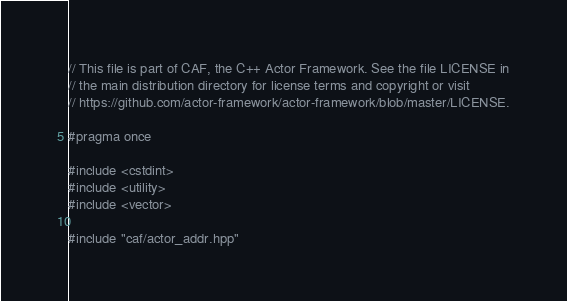Convert code to text. <code><loc_0><loc_0><loc_500><loc_500><_C++_>// This file is part of CAF, the C++ Actor Framework. See the file LICENSE in
// the main distribution directory for license terms and copyright or visit
// https://github.com/actor-framework/actor-framework/blob/master/LICENSE.

#pragma once

#include <cstdint>
#include <utility>
#include <vector>

#include "caf/actor_addr.hpp"</code> 